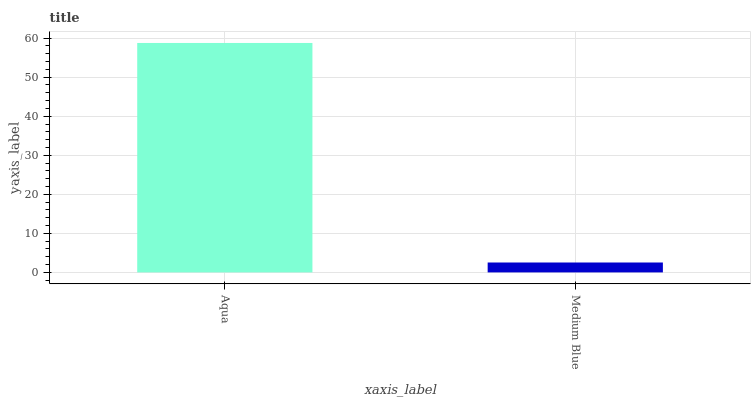Is Medium Blue the minimum?
Answer yes or no. Yes. Is Aqua the maximum?
Answer yes or no. Yes. Is Medium Blue the maximum?
Answer yes or no. No. Is Aqua greater than Medium Blue?
Answer yes or no. Yes. Is Medium Blue less than Aqua?
Answer yes or no. Yes. Is Medium Blue greater than Aqua?
Answer yes or no. No. Is Aqua less than Medium Blue?
Answer yes or no. No. Is Aqua the high median?
Answer yes or no. Yes. Is Medium Blue the low median?
Answer yes or no. Yes. Is Medium Blue the high median?
Answer yes or no. No. Is Aqua the low median?
Answer yes or no. No. 